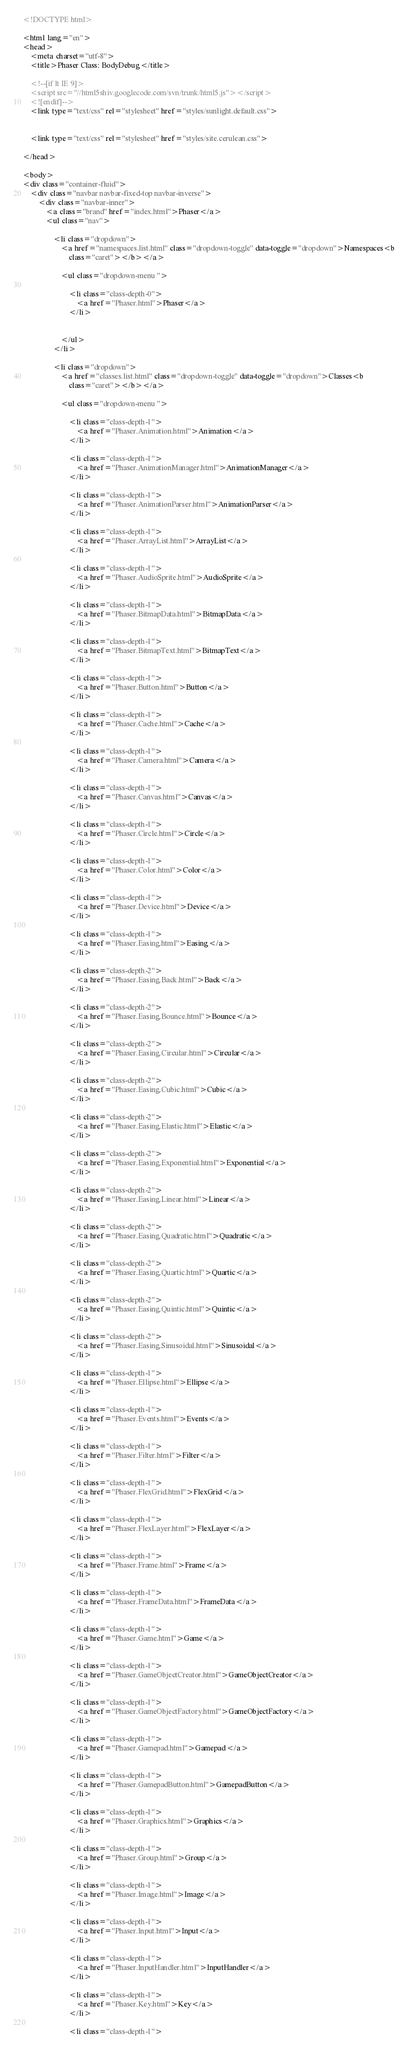Convert code to text. <code><loc_0><loc_0><loc_500><loc_500><_HTML_><!DOCTYPE html>

<html lang="en">
<head>
	<meta charset="utf-8">
	<title>Phaser Class: BodyDebug</title>

	<!--[if lt IE 9]>
	<script src="//html5shiv.googlecode.com/svn/trunk/html5.js"></script>
	<![endif]-->
	<link type="text/css" rel="stylesheet" href="styles/sunlight.default.css">

	
	<link type="text/css" rel="stylesheet" href="styles/site.cerulean.css">
	
</head>

<body>
<div class="container-fluid">
	<div class="navbar navbar-fixed-top navbar-inverse">
		<div class="navbar-inner">
			<a class="brand" href="index.html">Phaser</a>
			<ul class="nav">
				
				<li class="dropdown">
					<a href="namespaces.list.html" class="dropdown-toggle" data-toggle="dropdown">Namespaces<b
						class="caret"></b></a>

					<ul class="dropdown-menu ">
						
						<li class="class-depth-0">
							<a href="Phaser.html">Phaser</a>
						</li>
						

					</ul>
				</li>
				
				<li class="dropdown">
					<a href="classes.list.html" class="dropdown-toggle" data-toggle="dropdown">Classes<b
						class="caret"></b></a>

					<ul class="dropdown-menu ">
						
						<li class="class-depth-1">
							<a href="Phaser.Animation.html">Animation</a>
						</li>
						
						<li class="class-depth-1">
							<a href="Phaser.AnimationManager.html">AnimationManager</a>
						</li>
						
						<li class="class-depth-1">
							<a href="Phaser.AnimationParser.html">AnimationParser</a>
						</li>
						
						<li class="class-depth-1">
							<a href="Phaser.ArrayList.html">ArrayList</a>
						</li>
						
						<li class="class-depth-1">
							<a href="Phaser.AudioSprite.html">AudioSprite</a>
						</li>
						
						<li class="class-depth-1">
							<a href="Phaser.BitmapData.html">BitmapData</a>
						</li>
						
						<li class="class-depth-1">
							<a href="Phaser.BitmapText.html">BitmapText</a>
						</li>
						
						<li class="class-depth-1">
							<a href="Phaser.Button.html">Button</a>
						</li>
						
						<li class="class-depth-1">
							<a href="Phaser.Cache.html">Cache</a>
						</li>
						
						<li class="class-depth-1">
							<a href="Phaser.Camera.html">Camera</a>
						</li>
						
						<li class="class-depth-1">
							<a href="Phaser.Canvas.html">Canvas</a>
						</li>
						
						<li class="class-depth-1">
							<a href="Phaser.Circle.html">Circle</a>
						</li>
						
						<li class="class-depth-1">
							<a href="Phaser.Color.html">Color</a>
						</li>
						
						<li class="class-depth-1">
							<a href="Phaser.Device.html">Device</a>
						</li>
						
						<li class="class-depth-1">
							<a href="Phaser.Easing.html">Easing</a>
						</li>
						
						<li class="class-depth-2">
							<a href="Phaser.Easing.Back.html">Back</a>
						</li>
						
						<li class="class-depth-2">
							<a href="Phaser.Easing.Bounce.html">Bounce</a>
						</li>
						
						<li class="class-depth-2">
							<a href="Phaser.Easing.Circular.html">Circular</a>
						</li>
						
						<li class="class-depth-2">
							<a href="Phaser.Easing.Cubic.html">Cubic</a>
						</li>
						
						<li class="class-depth-2">
							<a href="Phaser.Easing.Elastic.html">Elastic</a>
						</li>
						
						<li class="class-depth-2">
							<a href="Phaser.Easing.Exponential.html">Exponential</a>
						</li>
						
						<li class="class-depth-2">
							<a href="Phaser.Easing.Linear.html">Linear</a>
						</li>
						
						<li class="class-depth-2">
							<a href="Phaser.Easing.Quadratic.html">Quadratic</a>
						</li>
						
						<li class="class-depth-2">
							<a href="Phaser.Easing.Quartic.html">Quartic</a>
						</li>
						
						<li class="class-depth-2">
							<a href="Phaser.Easing.Quintic.html">Quintic</a>
						</li>
						
						<li class="class-depth-2">
							<a href="Phaser.Easing.Sinusoidal.html">Sinusoidal</a>
						</li>
						
						<li class="class-depth-1">
							<a href="Phaser.Ellipse.html">Ellipse</a>
						</li>
						
						<li class="class-depth-1">
							<a href="Phaser.Events.html">Events</a>
						</li>
						
						<li class="class-depth-1">
							<a href="Phaser.Filter.html">Filter</a>
						</li>
						
						<li class="class-depth-1">
							<a href="Phaser.FlexGrid.html">FlexGrid</a>
						</li>
						
						<li class="class-depth-1">
							<a href="Phaser.FlexLayer.html">FlexLayer</a>
						</li>
						
						<li class="class-depth-1">
							<a href="Phaser.Frame.html">Frame</a>
						</li>
						
						<li class="class-depth-1">
							<a href="Phaser.FrameData.html">FrameData</a>
						</li>
						
						<li class="class-depth-1">
							<a href="Phaser.Game.html">Game</a>
						</li>
						
						<li class="class-depth-1">
							<a href="Phaser.GameObjectCreator.html">GameObjectCreator</a>
						</li>
						
						<li class="class-depth-1">
							<a href="Phaser.GameObjectFactory.html">GameObjectFactory</a>
						</li>
						
						<li class="class-depth-1">
							<a href="Phaser.Gamepad.html">Gamepad</a>
						</li>
						
						<li class="class-depth-1">
							<a href="Phaser.GamepadButton.html">GamepadButton</a>
						</li>
						
						<li class="class-depth-1">
							<a href="Phaser.Graphics.html">Graphics</a>
						</li>
						
						<li class="class-depth-1">
							<a href="Phaser.Group.html">Group</a>
						</li>
						
						<li class="class-depth-1">
							<a href="Phaser.Image.html">Image</a>
						</li>
						
						<li class="class-depth-1">
							<a href="Phaser.Input.html">Input</a>
						</li>
						
						<li class="class-depth-1">
							<a href="Phaser.InputHandler.html">InputHandler</a>
						</li>
						
						<li class="class-depth-1">
							<a href="Phaser.Key.html">Key</a>
						</li>
						
						<li class="class-depth-1"></code> 